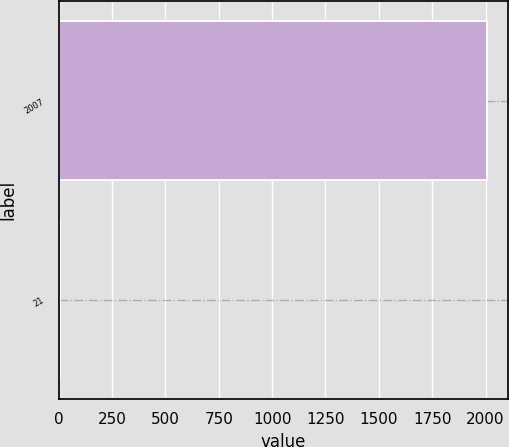<chart> <loc_0><loc_0><loc_500><loc_500><bar_chart><fcel>2007<fcel>21<nl><fcel>2006<fcel>7<nl></chart> 